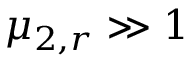Convert formula to latex. <formula><loc_0><loc_0><loc_500><loc_500>\mu _ { 2 , r } \gg 1</formula> 